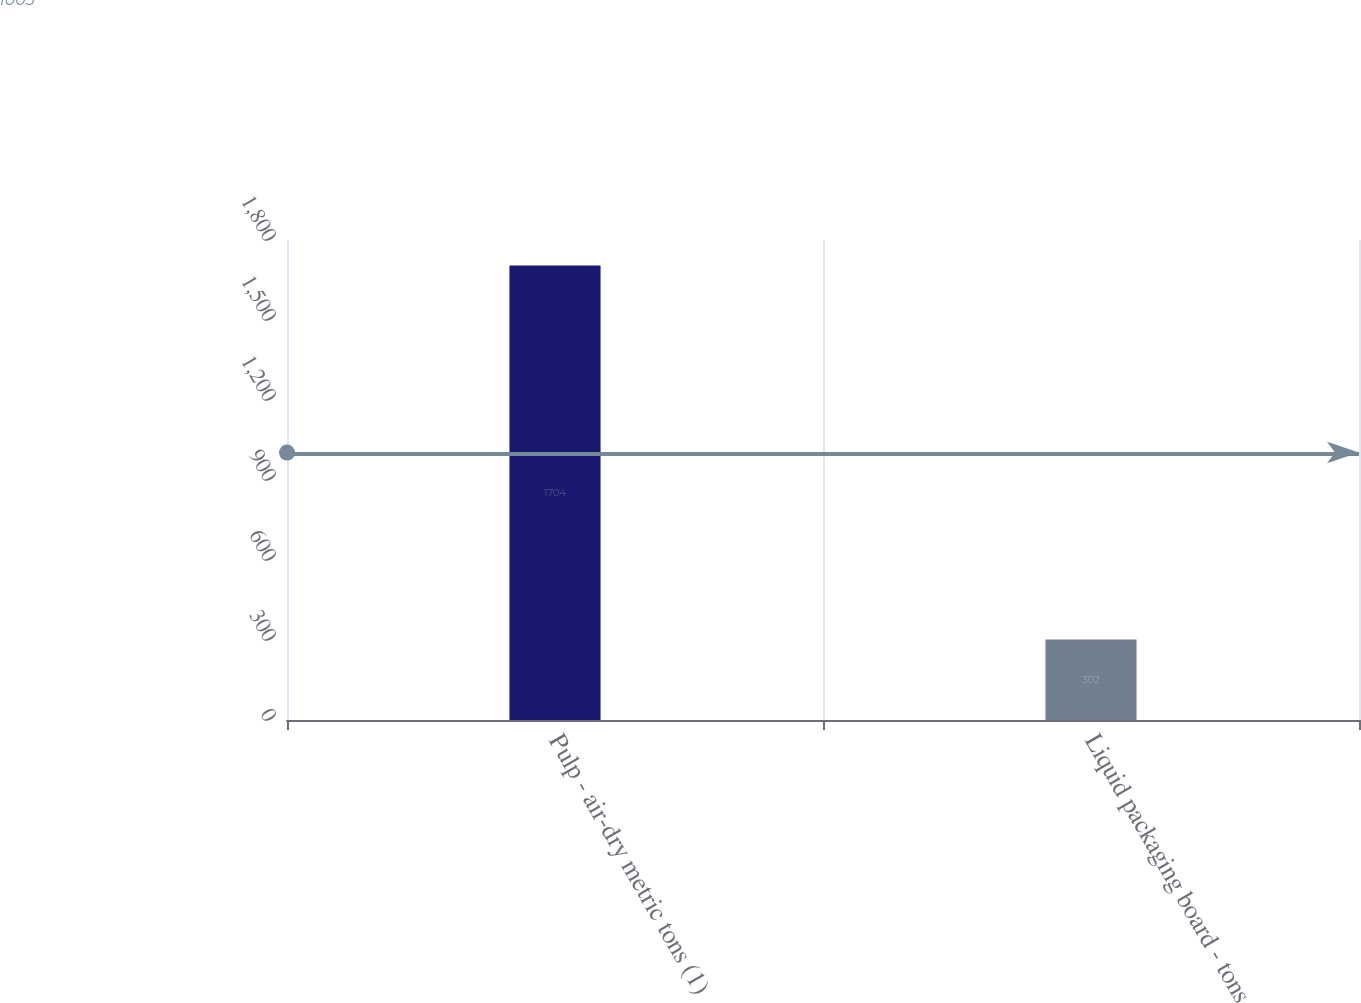<chart> <loc_0><loc_0><loc_500><loc_500><bar_chart><fcel>Pulp - air-dry metric tons (1)<fcel>Liquid packaging board - tons<nl><fcel>1704<fcel>302<nl></chart> 